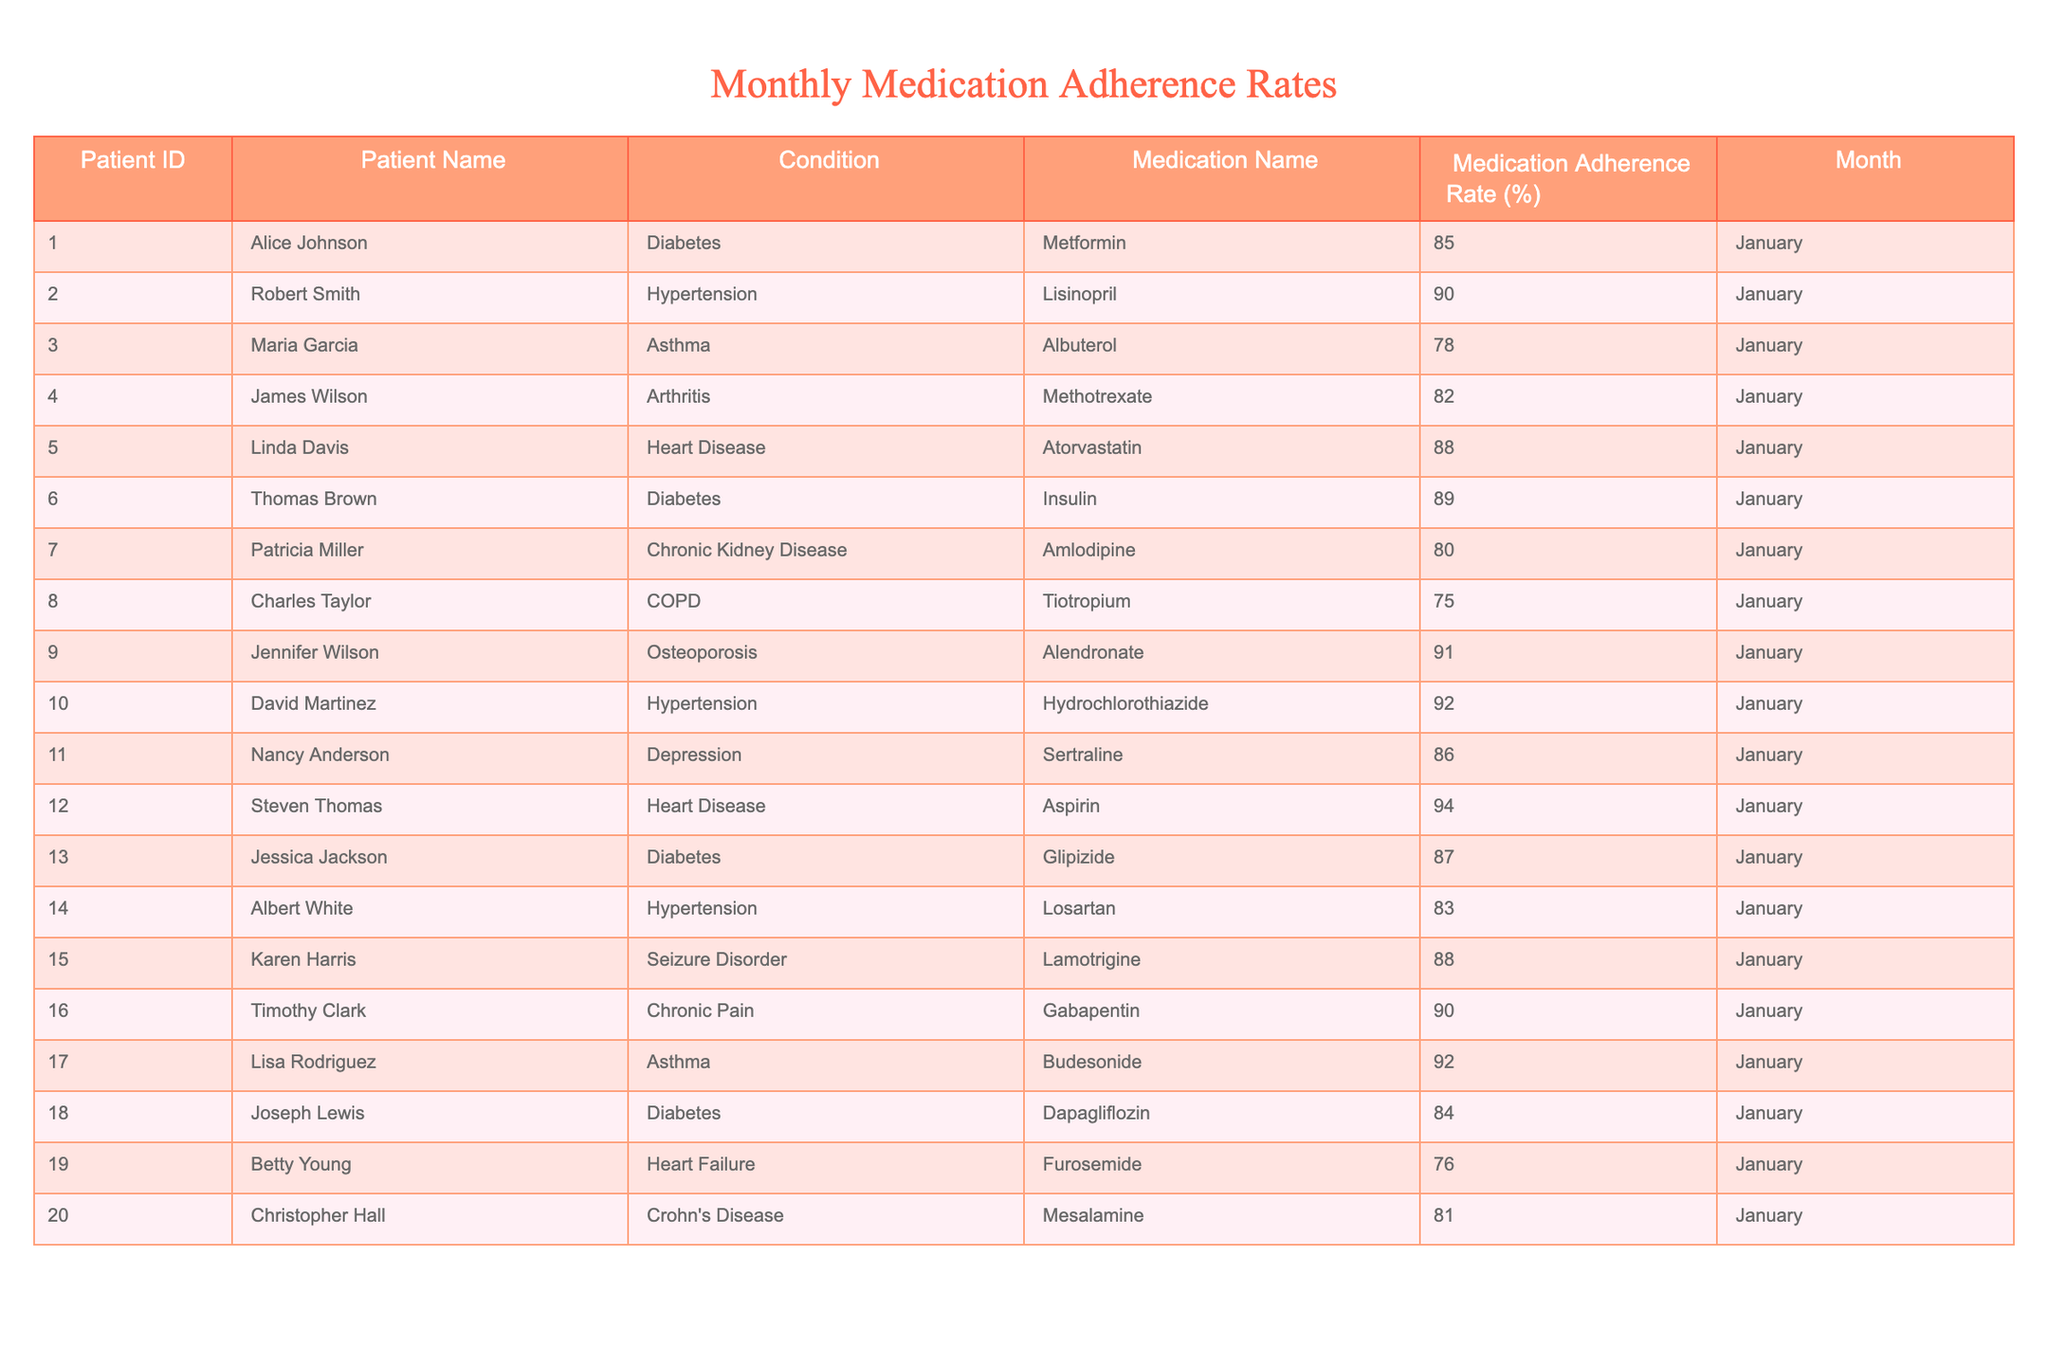What is the medication adherence rate for David Martinez? The table shows that David Martinez has a medication adherence rate of 92%, as indicated under the Medication Adherence Rate column for Hypertension and Hydrochlorothiazide.
Answer: 92% Which patient has the lowest adherence rate? In the table, Charles Taylor has the lowest medication adherence rate of 75%, documented for COPD and Tiotropium.
Answer: 75% What is the average medication adherence rate for patients with Diabetes? The adherence rates for Diabetes patients (Alice Johnson, Thomas Brown, Jessica Jackson, and Joseph Lewis) are 85%, 89%, 87%, and 84%. Adding them up gives 85 + 89 + 87 + 84 = 345. There are 4 patients, so the average is 345 / 4 = 86.25.
Answer: 86.25 Is there a patient named Linda Davis in the table? Yes, Linda Davis is listed in the table as having Heart Disease with a medication adherence rate of 88%.
Answer: Yes How many patients have a medication adherence rate above 90%? From the table, the patients with adherence rates above 90% are Jennifer Wilson (91%), David Martinez (92%), Steven Thomas (94%), and Lisa Rodriguez (92%). This totals to four patients.
Answer: Four What is the difference in adherence rates between the highest and lowest rates among patients with Heart Disease? The adherence rates for Heart Disease patients (Linda Davis and Steven Thomas) are 88% and 94%. The difference is calculated by subtracting: 94 - 88 = 6.
Answer: 6 Which patient has a higher adherence rate: Robert Smith or Albert White? Robert Smith has a medication adherence rate of 90% while Albert White has an adherence rate of 83%. Since 90% is greater than 83%, Robert Smith has the higher rate.
Answer: Robert Smith What is the total medication adherence rate for all patients listed in the table? First, we sum up all the adherence rates: 85 + 90 + 78 + 82 + 88 + 89 + 80 + 75 + 91 + 92 + 86 + 94 + 87 + 83 + 88 + 90 + 92 + 84 + 76 + 81 = 1735. There are 20 patients, so the total adherence rate is 1735.
Answer: 1735 Are there any patients with an adherence rate below 80%? Yes, the table shows that there are two patients with rates below 80%: Maria Garcia (78%) and Charles Taylor (75%).
Answer: Yes How does the adherence rate for Patricia Miller compare to that of Nancy Anderson? Patricia Miller has an adherence rate of 88%, while Nancy Anderson has a rate of 86%. Since 88% is greater than 86%, Patricia Miller has a higher rate compared to Nancy Anderson.
Answer: Patricia Miller 